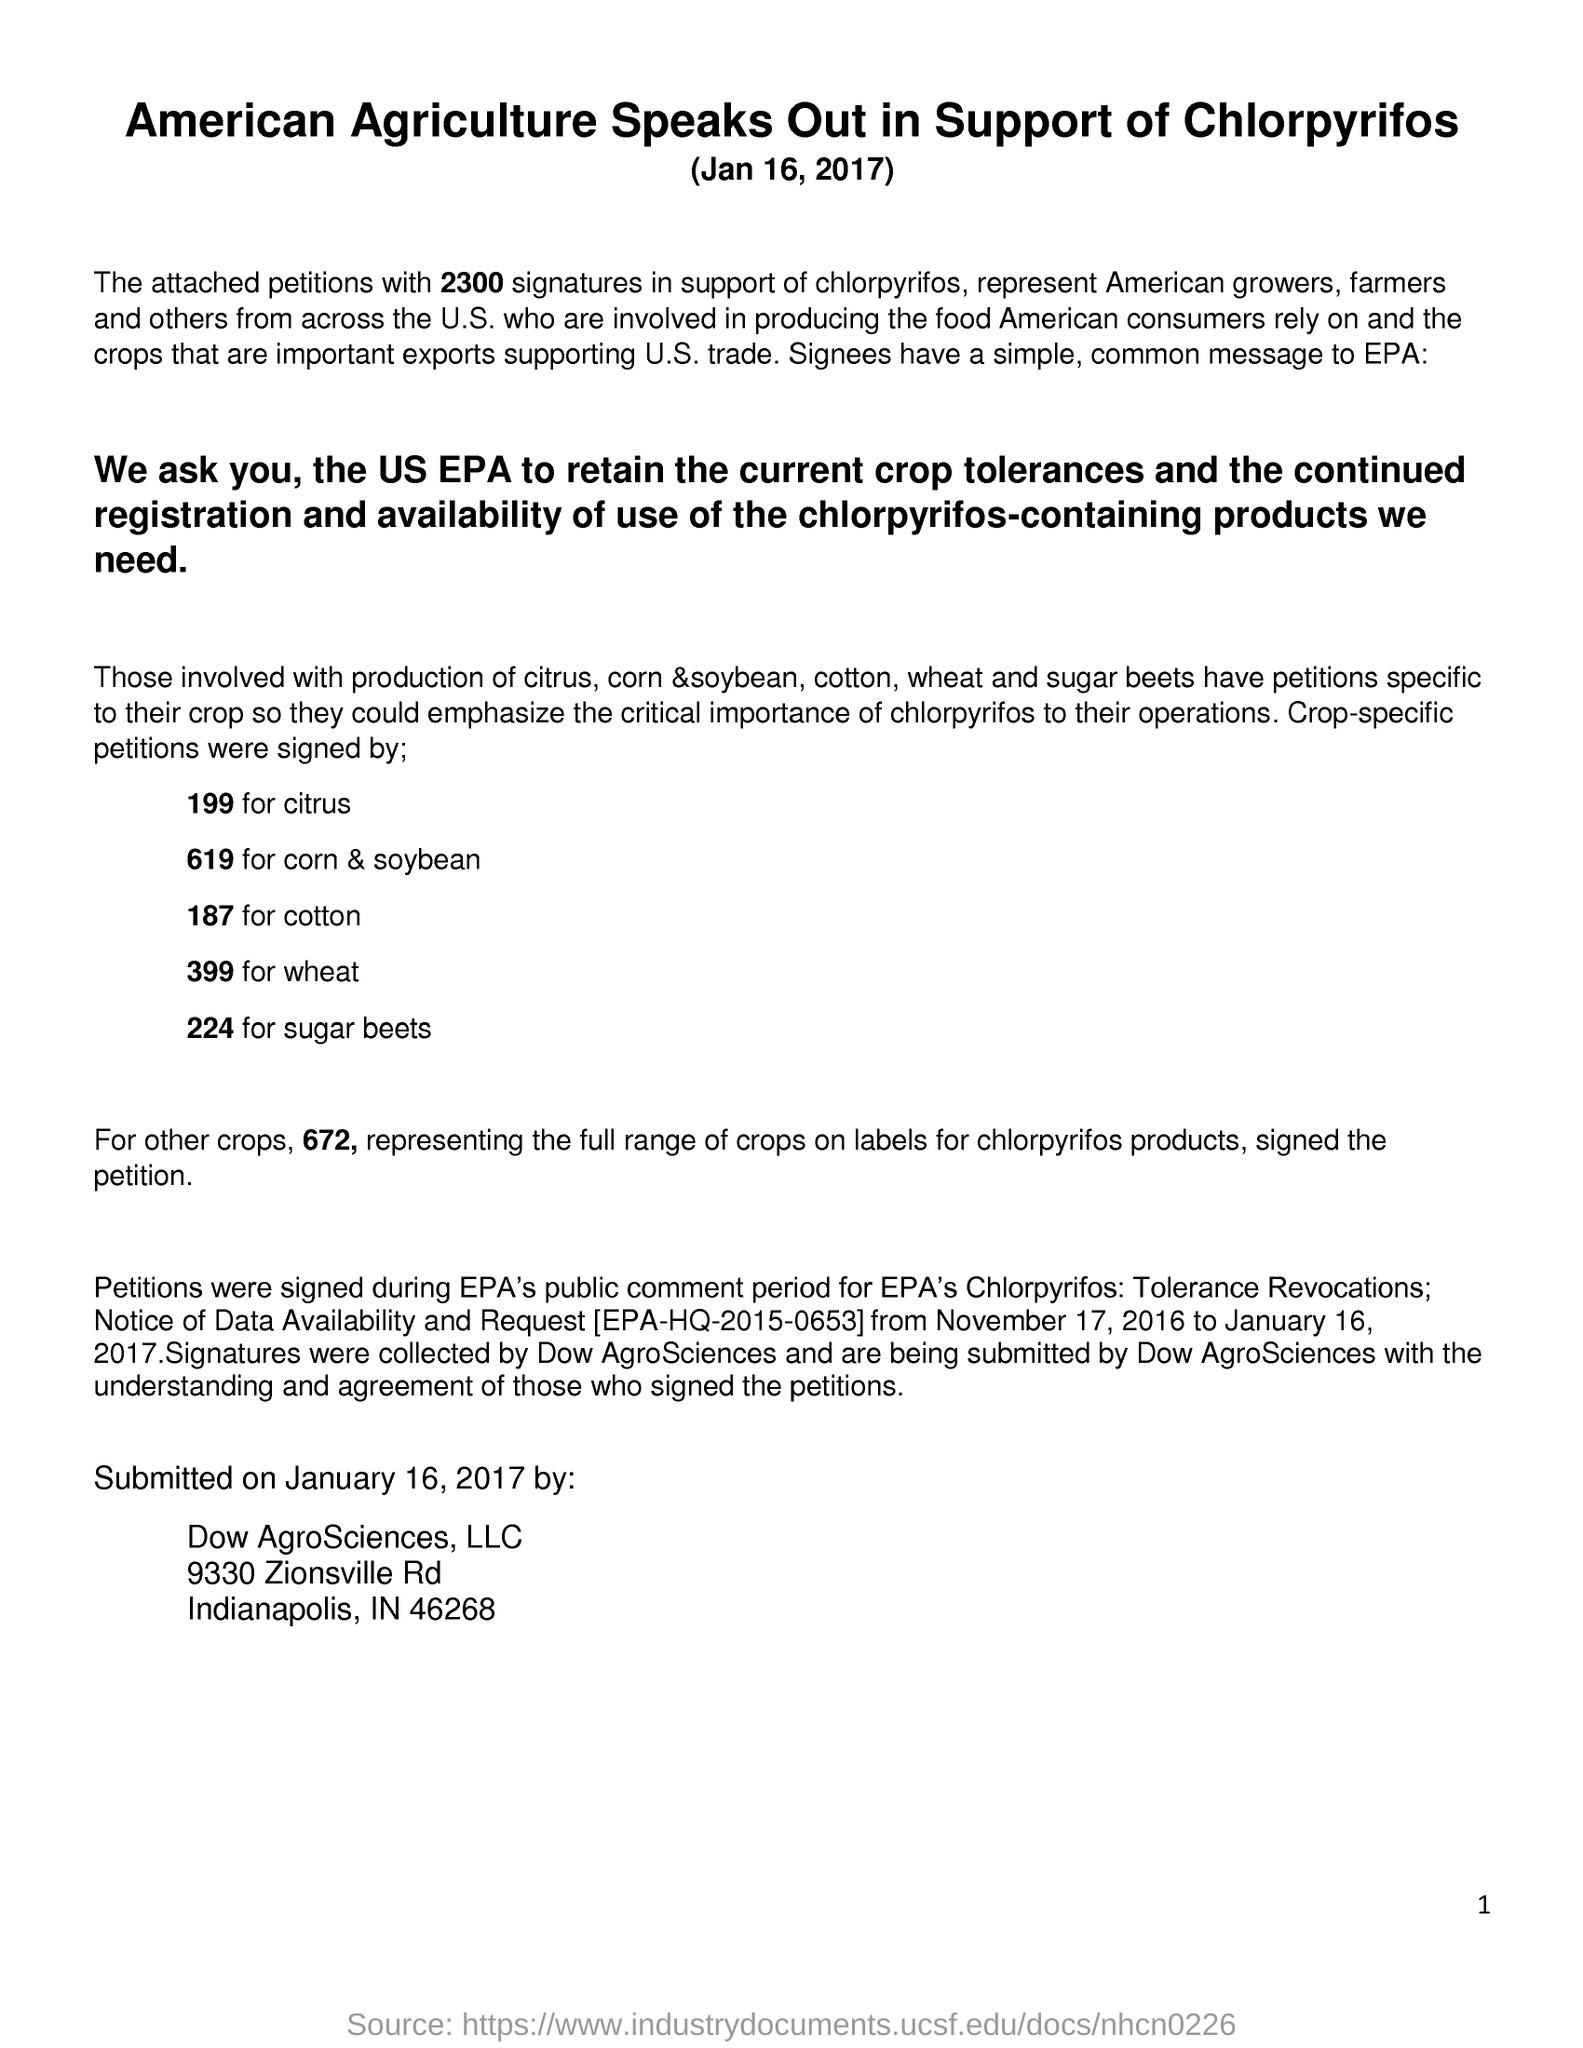Point out several critical features in this image. The number 224 represents sugar beets. The document is titled 'American Agriculture Speaks Out in Support of Chlorpyritos.' Citrus is represented by the number 199. 